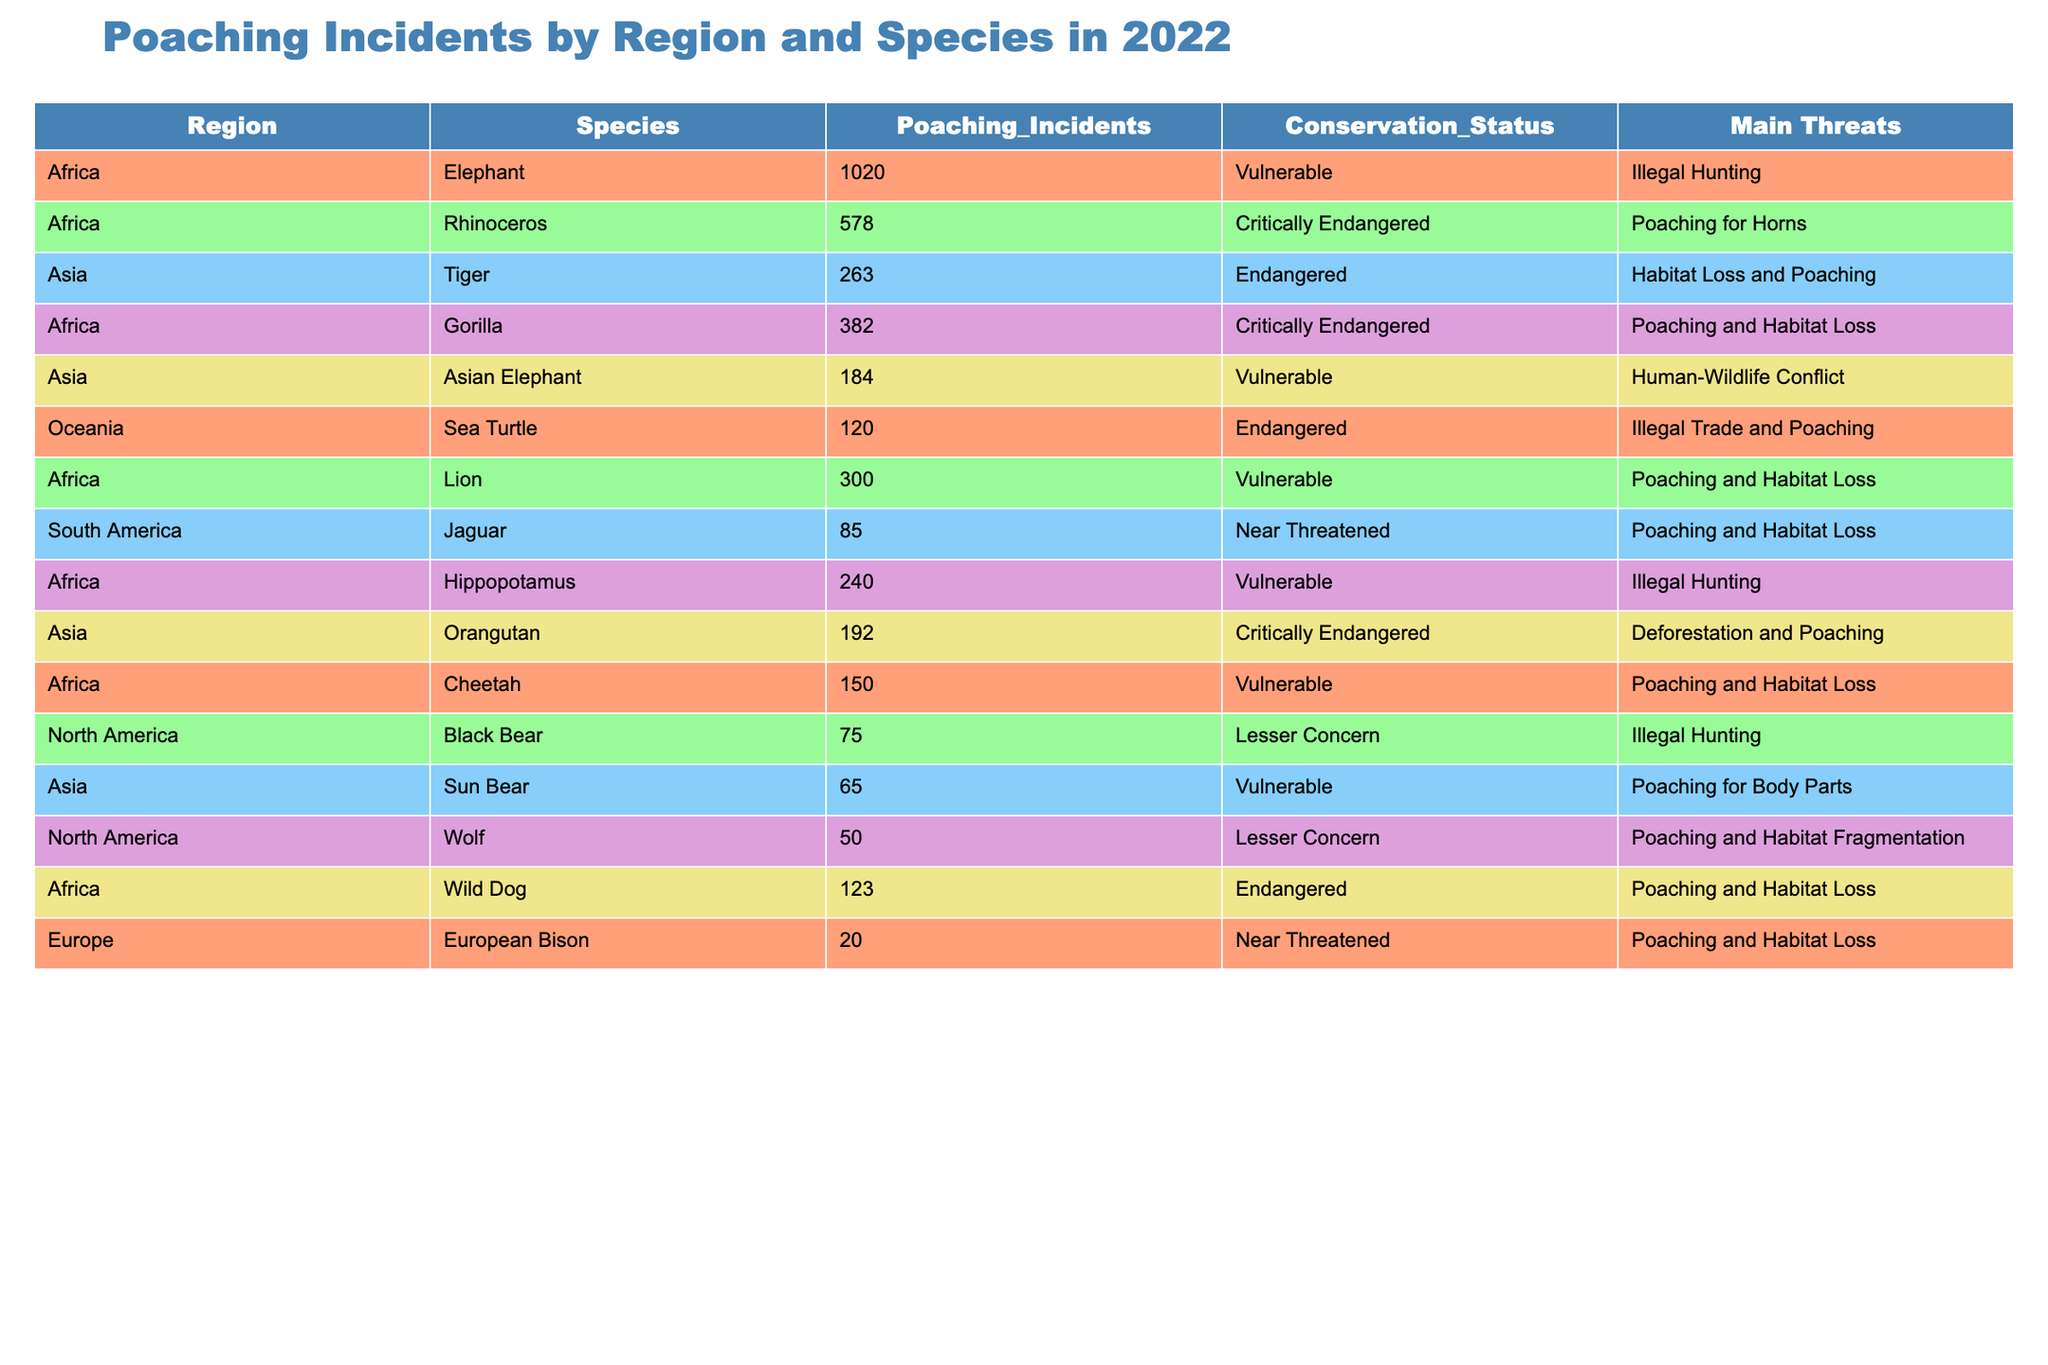What is the total number of poaching incidents reported in Africa? From the table, we can identify the poaching incidents for each species in Africa: Elephant (1020), Rhinoceros (578), Gorilla (382), Lion (300), Hippopotamus (240), Cheetah (150), Wild Dog (123). Summing these values gives: 1020 + 578 + 382 + 300 + 240 + 150 + 123 = 2793.
Answer: 2793 Which species had the highest number of poaching incidents in 2022? By examining the Poaching_Incidents column, we see that the Elephant has 1020 incidents, which is greater than any other species listed.
Answer: Elephant Is the Sea Turtle species classified as endangered according to the table? The table shows that the Sea Turtle species is labeled as Endangered in the Conservation_Status column. Therefore, the answer is yes.
Answer: Yes How many poaching incidents were reported for critically endangered species? The critically endangered species listed are Rhinoceros (578), Gorilla (382), and Orangutan (192). Adding these values results in: 578 + 382 + 192 = 1152.
Answer: 1152 Are there more poaching incidents for Lions or for Tigers? The table shows that Lions have 300 incidents and Tigers have 263 incidents. Since 300 is greater than 263, Lions had more poaching incidents.
Answer: Lions What is the average number of poaching incidents for species in Asia? The Asian species and their incidents are Tiger (263), Asian Elephant (184), and Orangutan (192). To find the average: (263 + 184 + 192) = 639, and there are 3 species, so the average is 639 / 3 = 213.
Answer: 213 Does the table indicate that illegal hunting is a main threat for elephants? According to the table, the Main Threats for Elephants is listed as Illegal Hunting. Therefore, the answer is true.
Answer: Yes What is the difference in the number of poaching incidents between the highest and lowest reported species? The highest reported species is Elephant (1020) and the lowest is European Bison (20). The difference is calculated by subtracting the lowest from the highest: 1020 - 20 = 1000.
Answer: 1000 Which region has the least number of poaching incidents reported, and what is that number? The South America region has the Jaguar listed with only 85 poaching incidents, which is lower than any other region's total species counts.
Answer: 85 